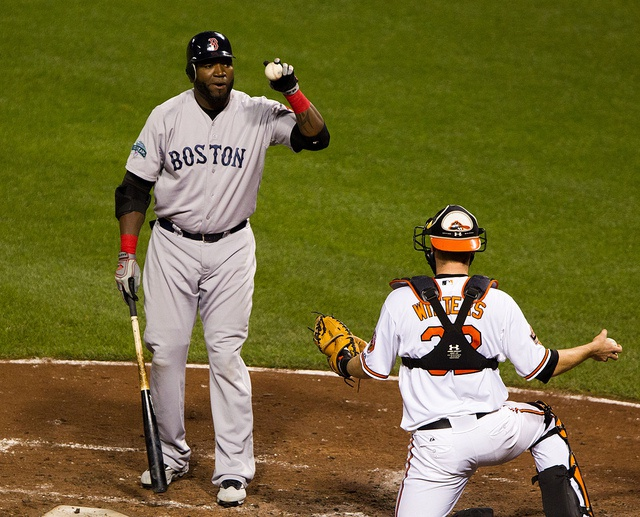Describe the objects in this image and their specific colors. I can see people in darkgreen, lightgray, darkgray, and black tones, people in darkgreen, lavender, black, olive, and darkgray tones, baseball bat in darkgreen, black, gray, olive, and tan tones, baseball glove in darkgreen, orange, black, and olive tones, and baseball glove in darkgreen, black, beige, and tan tones in this image. 